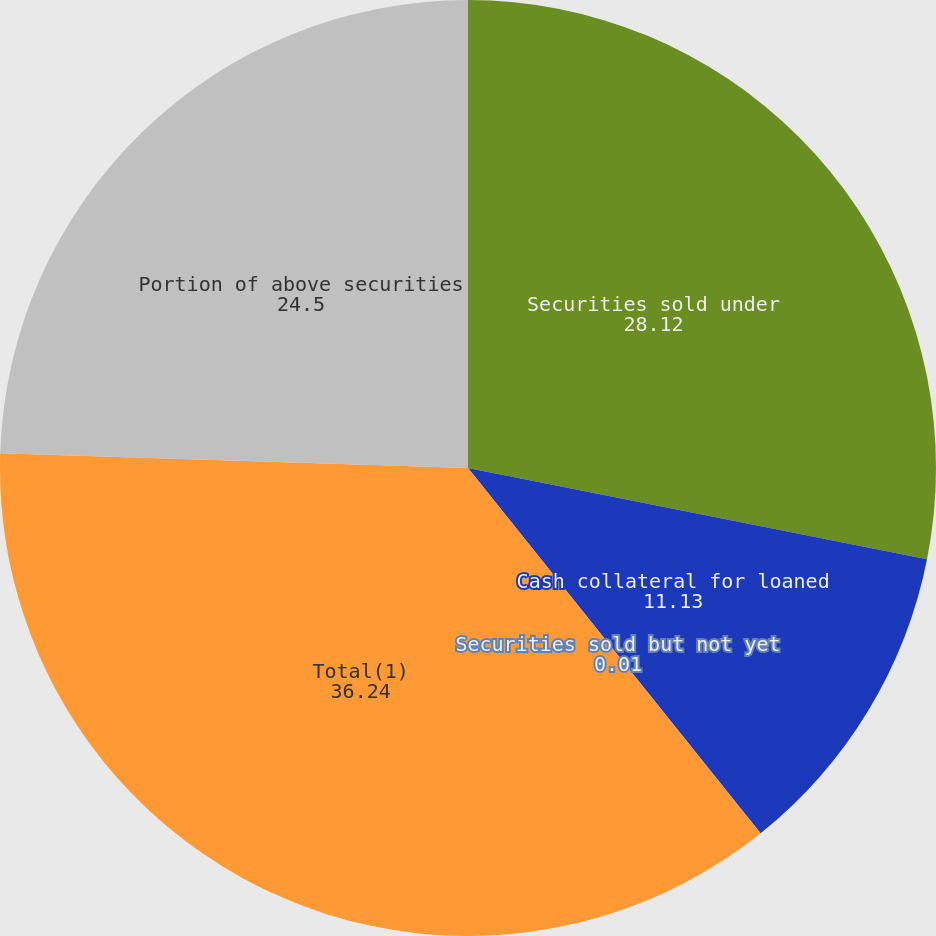Convert chart. <chart><loc_0><loc_0><loc_500><loc_500><pie_chart><fcel>Securities sold under<fcel>Cash collateral for loaned<fcel>Securities sold but not yet<fcel>Total(1)<fcel>Portion of above securities<nl><fcel>28.12%<fcel>11.13%<fcel>0.01%<fcel>36.24%<fcel>24.5%<nl></chart> 